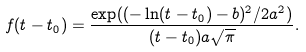<formula> <loc_0><loc_0><loc_500><loc_500>f ( t - t _ { 0 } ) = \frac { \exp ( ( - \ln ( t - t _ { 0 } ) - b ) ^ { 2 } / 2 a ^ { 2 } ) } { ( t - t _ { 0 } ) a { \sqrt { \pi } } } .</formula> 